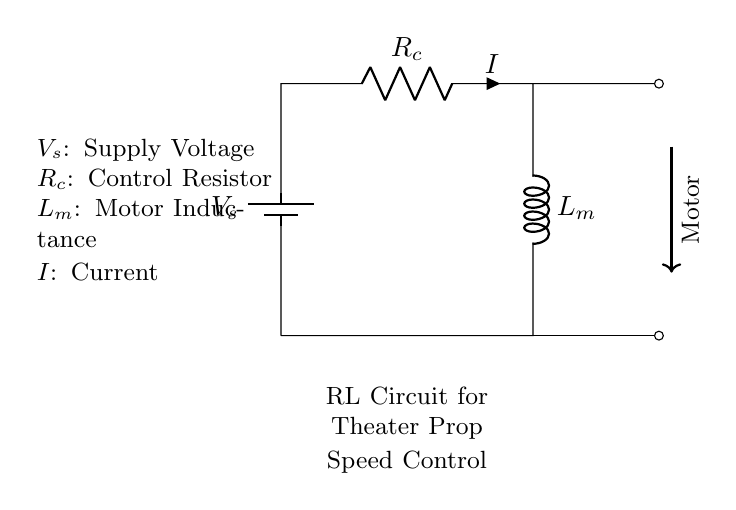What is the purpose of the resistor in this circuit? The purpose of the resistor in this circuit is to control the current flowing through the inductor and motor, which ultimately affects the speed of the motor. The resistor limits the maximum current, allowing for fine control of motor speed based on varying resistance values.
Answer: Control current What does L_m represent in this circuit? L_m represents the inductance of the motor. Inductance is a property that opposes changes in current, which is essential for smoothing out the current fluctuations and maintaining a stable operation in motor speed control applications.
Answer: Inductance What is indicated by the arrow in this circuit? The arrow indicates the direction of current flow from the voltage source through the resistor, inductor, and motor. It helps visualize how the circuit operates, making it clear which direction the electrons are moving within the circuit.
Answer: Current flow direction How would increasing R_c affect the motor speed? Increasing R_c (the control resistor) would increase the overall resistance in the circuit. According to Ohm's Law, this would reduce the current flowing through the motor, resulting in a lower motor speed. Thus, a higher resistance leads to the motor running slower.
Answer: Motor speed decreases What does the symbol representing the battery signify in this circuit? The symbol representing the battery signifies the source of electrical energy supplied to the circuit. It establishes the voltage difference needed to drive current through the components (resistor, inductor, motor) and power the motor for motion.
Answer: Voltage source What happens to the current immediately after turning on the switch in an RL circuit like this? Immediately after turning on the switch, the current will not reach its maximum value instantaneously due to the inductor's property of opposing changes in current. The current will gradually increase over time following an exponential curve until it stabilizes, reflecting the inductive response of the circuit.
Answer: Current increases gradually How does the RL circuit help with motor speed control? The RL circuit helps with motor speed control by using the resistor to adjust the current that flows through the motor, affecting its speed. The inductor smooths out the current changes, providing a steady flow that ensures the motor operates reliably at varying speeds. Adjusting the resistance allows for fine tuning of the speed.
Answer: Adjusts current for speed control 